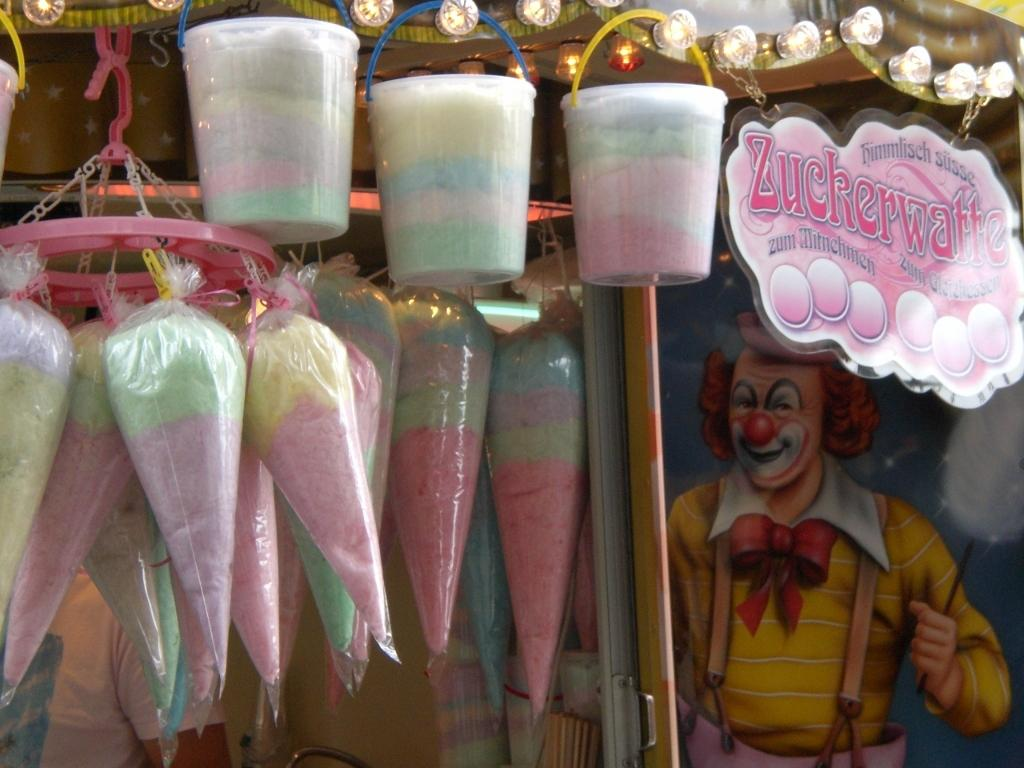What type of items are in the packets in the image? There are candy in packets in the image. How many packets can be seen in the image? There are packets in the image. What color is the board in the image? There is a pink board in the image. What type of illumination is present in the image? There are lights in the image. What kind of painting can be seen on the wall in the background of the image? There is a joker painting on the wall in the background of the image. What route does the grandfather take to reach the magic store in the image? There is no grandfather or magic store present in the image. 